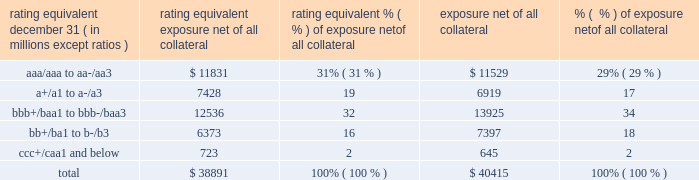Management 2019s discussion and analysis 118 jpmorgan chase & co./2018 form 10-k equivalent to the risk of loan exposures .
Dre is a less extreme measure of potential credit loss than peak and is used as an input for aggregating derivative credit risk exposures with loans and other credit risk .
Finally , avg is a measure of the expected fair value of the firm 2019s derivative receivables at future time periods , including the benefit of collateral .
Avg over the total life of the derivative contract is used as the primary metric for pricing purposes and is used to calculate credit risk capital and the cva , as further described below .
The fair value of the firm 2019s derivative receivables incorporates cva to reflect the credit quality of counterparties .
Cva is based on the firm 2019s avg to a counterparty and the counterparty 2019s credit spread in the credit derivatives market .
The firm believes that active risk management is essential to controlling the dynamic credit risk in the derivatives portfolio .
In addition , the firm 2019s risk management process takes into consideration the potential impact of wrong-way risk , which is broadly defined as the potential for increased correlation between the firm 2019s exposure to a counterparty ( avg ) and the counterparty 2019s credit quality .
Many factors may influence the nature and magnitude of these correlations over time .
To the extent that these correlations are identified , the firm may adjust the cva associated with that counterparty 2019s avg .
The firm risk manages exposure to changes in cva by entering into credit derivative contracts , as well as interest rate , foreign exchange , equity and commodity derivative contracts .
The accompanying graph shows exposure profiles to the firm 2019s current derivatives portfolio over the next 10 years as calculated by the peak , dre and avg metrics .
The three measures generally show that exposure will decline after the first year , if no new trades are added to the portfolio .
Exposure profile of derivatives measures december 31 , 2018 ( in billions ) the table summarizes the ratings profile of the firm 2019s derivative receivables , including credit derivatives , net of all collateral , at the dates indicated .
The ratings scale is based on the firm 2019s internal ratings , which generally correspond to the ratings as assigned by s&p and moody 2019s .
Ratings profile of derivative receivables .
As previously noted , the firm uses collateral agreements to mitigate counterparty credit risk .
The percentage of the firm 2019s over-the-counter derivative transactions subject to collateral agreements 2014 excluding foreign exchange spot trades , which are not typically covered by collateral agreements due to their short maturity and centrally cleared trades that are settled daily 2014 was approximately 90% ( 90 % ) at both december 31 , 2018 , and december 31 , 2017. .
What percentage of the 2018 derivative receivable ratings were ratings equivalent to junk bonds? 
Computations: (16 + 2)
Answer: 18.0. 